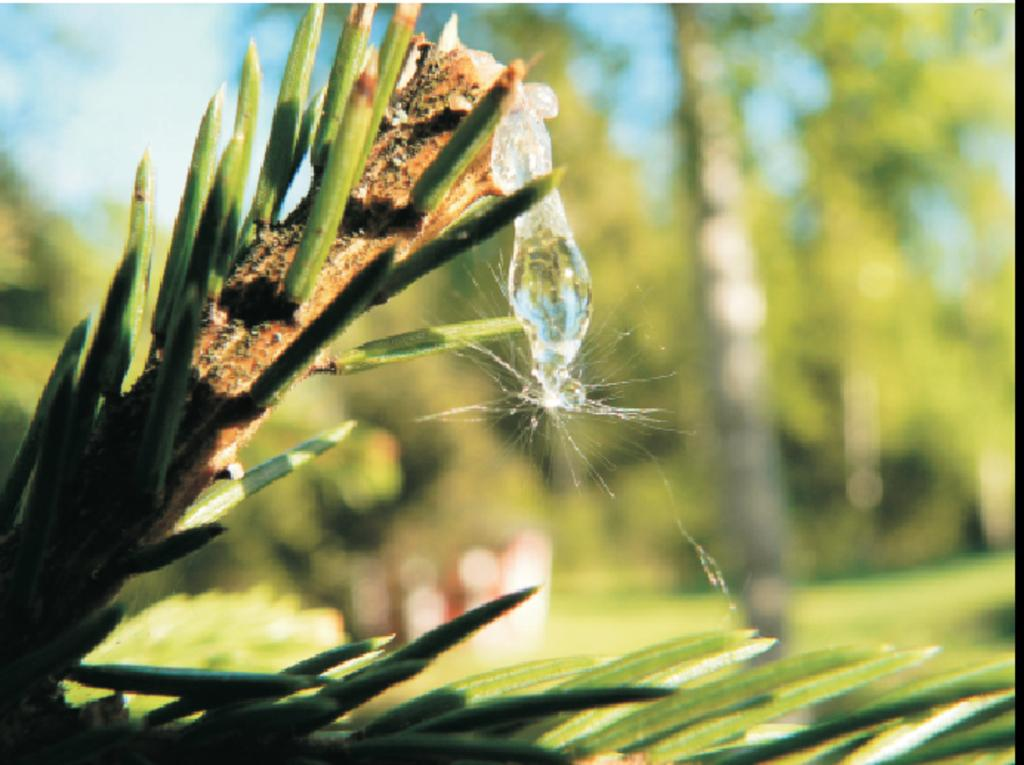What type of plant is present in the image? There is a plant with leaves in the image. Are there any living organisms on the plant? Yes, there is an insect on the plant. What can be seen in the background of the image? There are trees and grassland visible in the background of the image. What type of bread is being used to protest in the image? There is no bread or protest present in the image; it features a plant with leaves and an insect, along with trees and grassland in the background. 